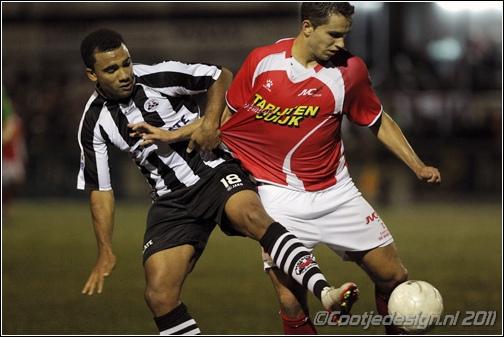What color is the man on the rights shirt?
Answer briefly. Red. What sport is being played?
Be succinct. Soccer. What are the men looking at?
Quick response, please. Ball. 